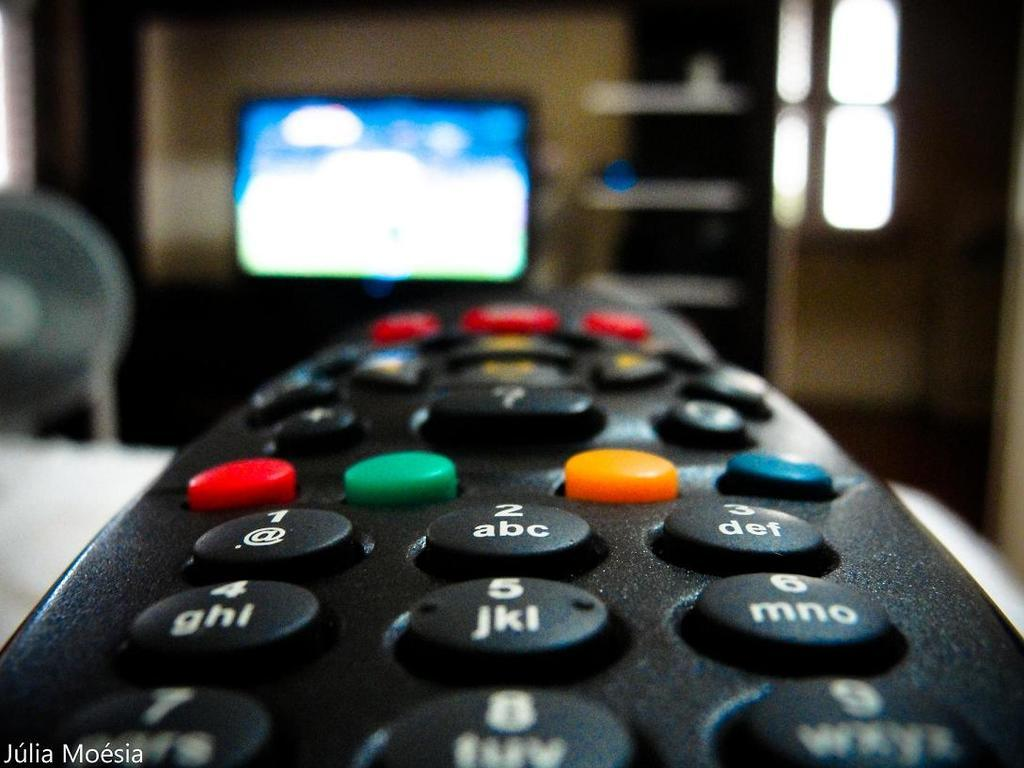Provide a one-sentence caption for the provided image. A photographed remote that says 'julia moesia' at the bottom of the picture. 